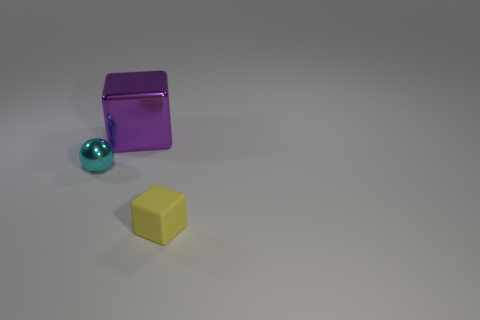Can you tell me the colors of all the objects seen in the image, and describe their positions relative to each other? Certainly! In the image, you'll see a large turquoise sphere located to the left, a purple cube in the center, and a yellow cube positioned to the right. The sphere and the central cube are closer to the foreground while the yellow cube is slightly behind them, creating a staggered arrangement. 